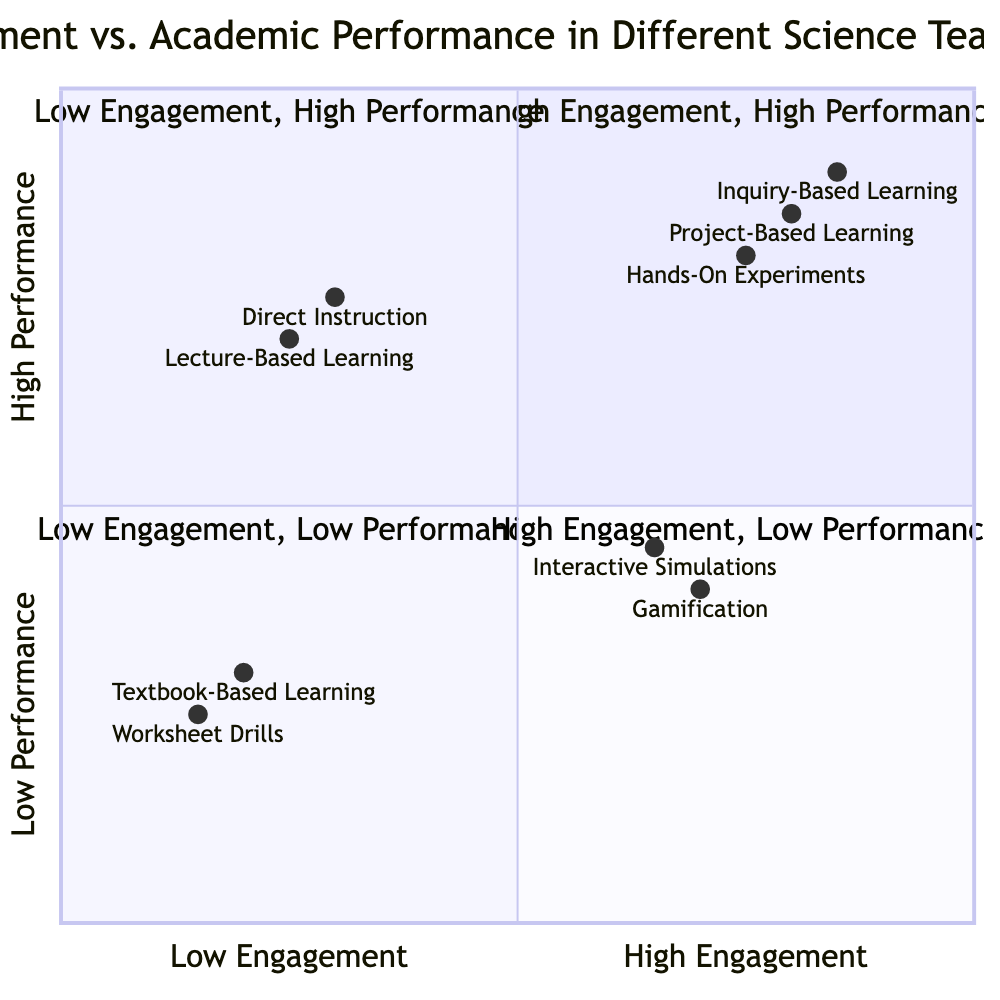What teaching strategy is located in the High Engagement, High Performance quadrant? In the diagram, the High Engagement, High Performance quadrant includes the teaching strategies Inquiry-Based Learning, Project-Based Learning, and Hands-On Experiments. The first listed strategy is Inquiry-Based Learning.
Answer: Inquiry-Based Learning Which teaching strategy has the highest engagement score? Examining the engagement scores from the diagram, Inquiry-Based Learning has the highest value at 0.85, which is the highest among all strategies.
Answer: Inquiry-Based Learning What is the academic performance score of Gamification? The academic performance score for Gamification is shown in the diagram as 0.40.
Answer: 0.40 How many teaching strategies are categorized in the Low Engagement, Low Performance quadrant? By counting the teaching strategies listed in the Low Engagement, Low Performance quadrant, we find two: Textbook-Based Learning and Worksheet Drills.
Answer: 2 Which quadrant contains Interactive Simulations? The diagram indicates that Interactive Simulations are located in the High Engagement, Low Performance quadrant, matching its characteristics of higher engagement but lower performance.
Answer: High Engagement, Low Performance What is the academic performance score of Direct Instruction? The diagram shows that the academic performance score for Direct Instruction is 0.75.
Answer: 0.75 Which teaching strategy has the lowest engagement score? Looking at the engagement scores provided in the diagram, Worksheet Drills have the lowest score at 0.15 among all listed strategies.
Answer: Worksheet Drills What is the range of engagement scores found in the High Engagement, High Performance quadrant? In the High Engagement, High Performance quadrant, the engagement scores for the strategies range from 0.75 to 0.85. Specifically, Inquiry-Based Learning is 0.85 and Hands-On Experiments is 0.75.
Answer: 0.75 to 0.85 What is the relationship between Gamification and Interactive Simulations regarding performance? Both Gamification and Interactive Simulations are in the Low Performance category, with Gamification at 0.40 and Interactive Simulations at 0.45, indicating that both have relatively low performance metrics.
Answer: Low Performance 